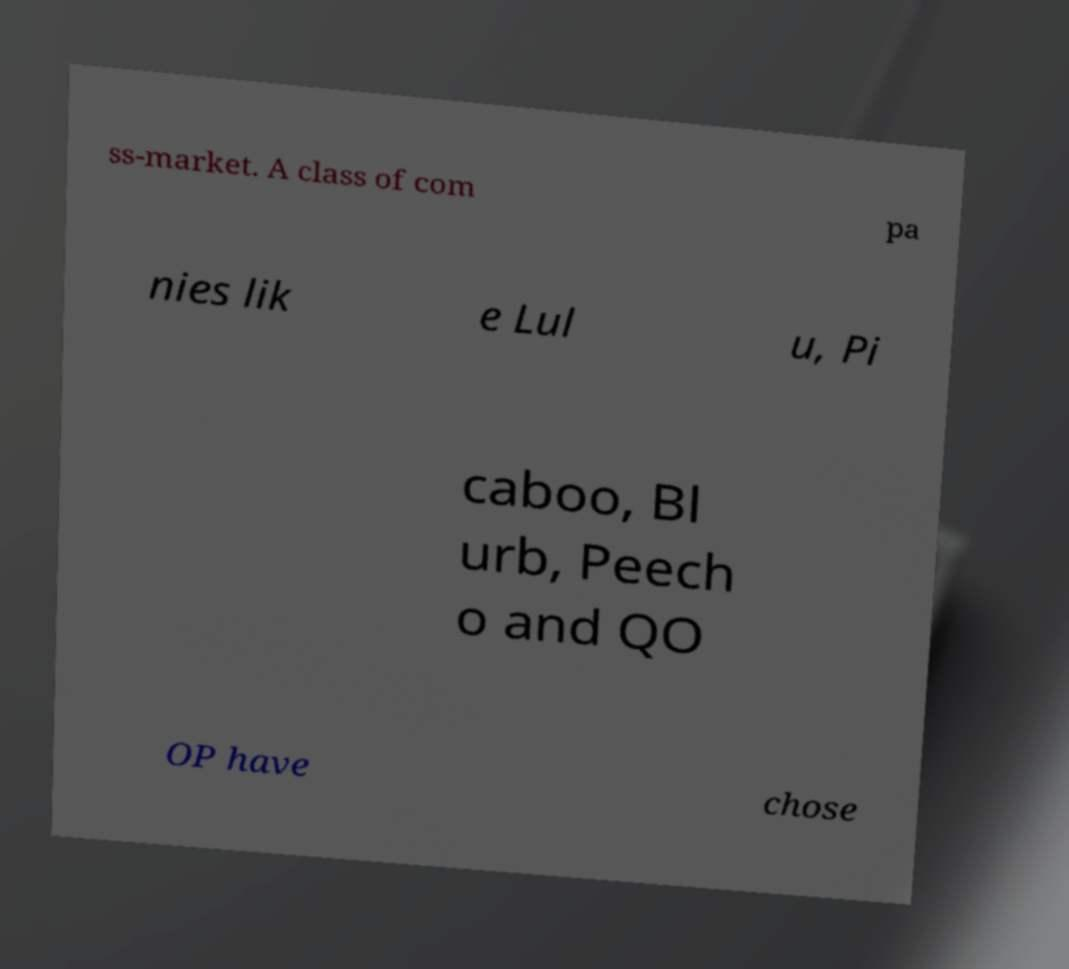What messages or text are displayed in this image? I need them in a readable, typed format. ss-market. A class of com pa nies lik e Lul u, Pi caboo, Bl urb, Peech o and QO OP have chose 